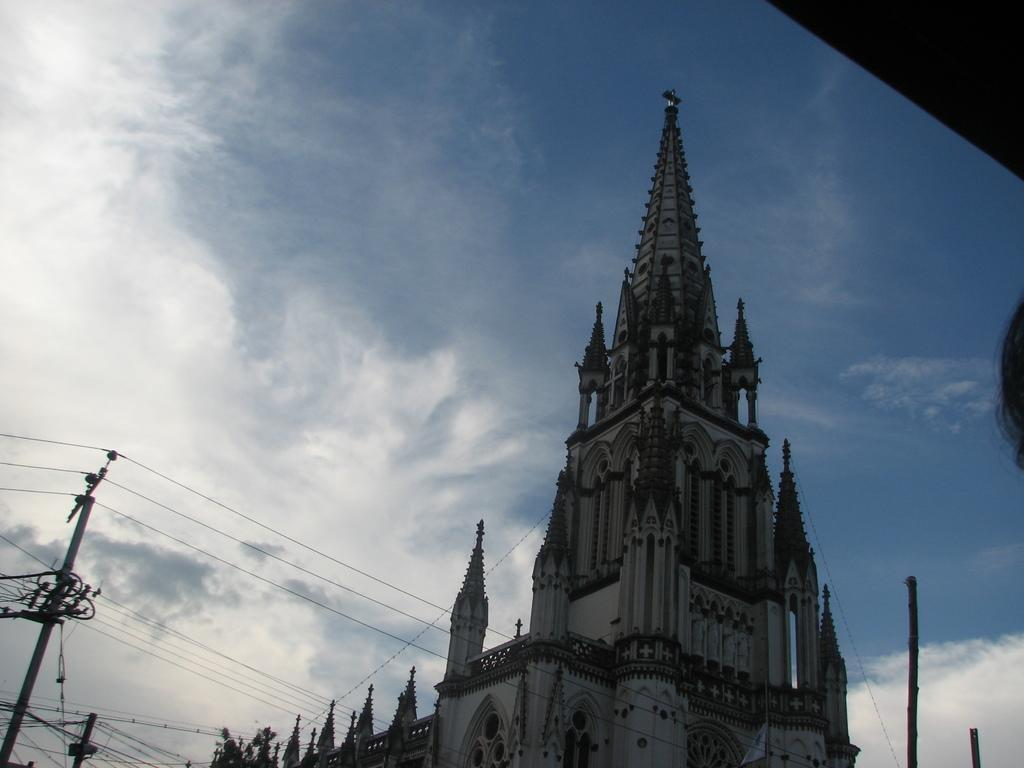What structure is present in the image? There is a building in the image. What can be seen on the left side of the image? There is a current pole on the left side of the image. What is visible in the background of the image? There are clouds and the sky visible in the background of the image. What type of canvas is being used to paint the building in the image? There is no canvas or painting present in the image; it is a photograph of a building and a current pole. Whose birthday is being celebrated in the image? There is no indication of a birthday celebration in the image. 